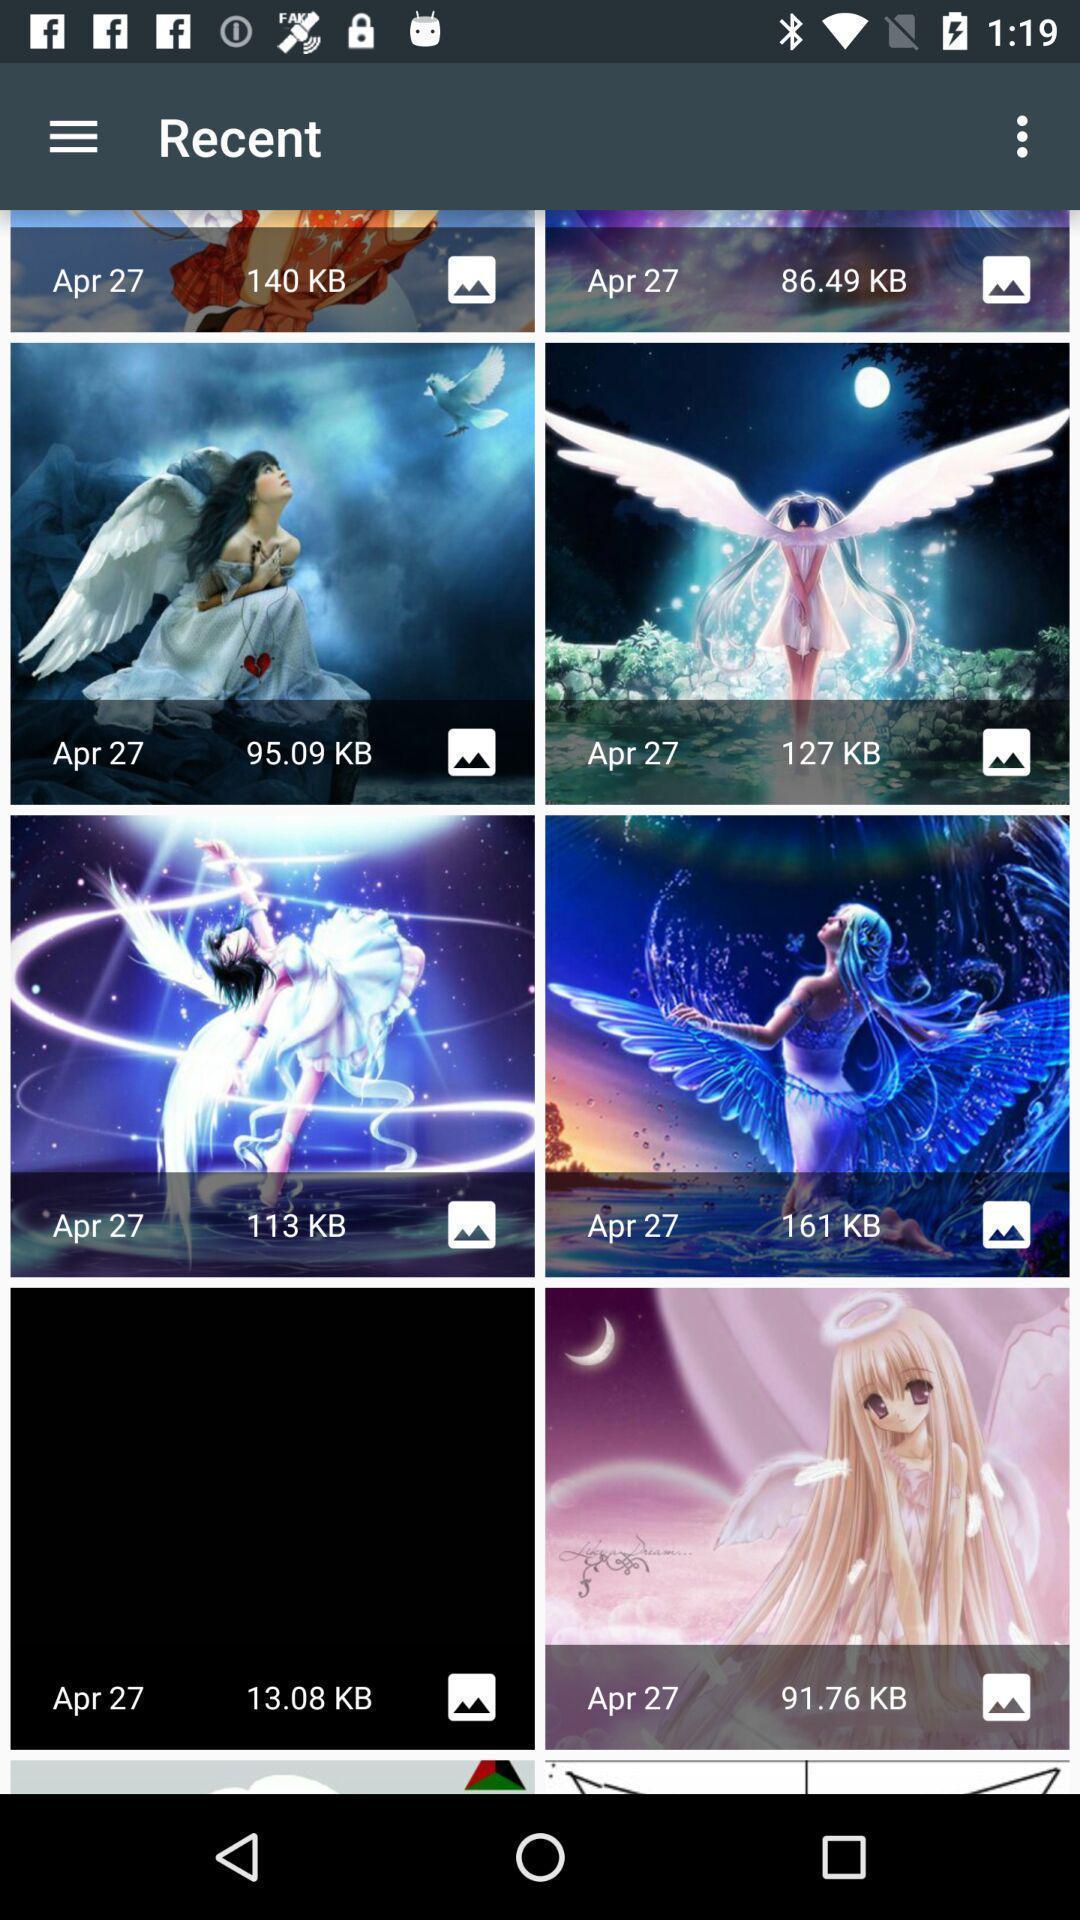Explain the elements present in this screenshot. Screen showing the thumbnails in recent. 